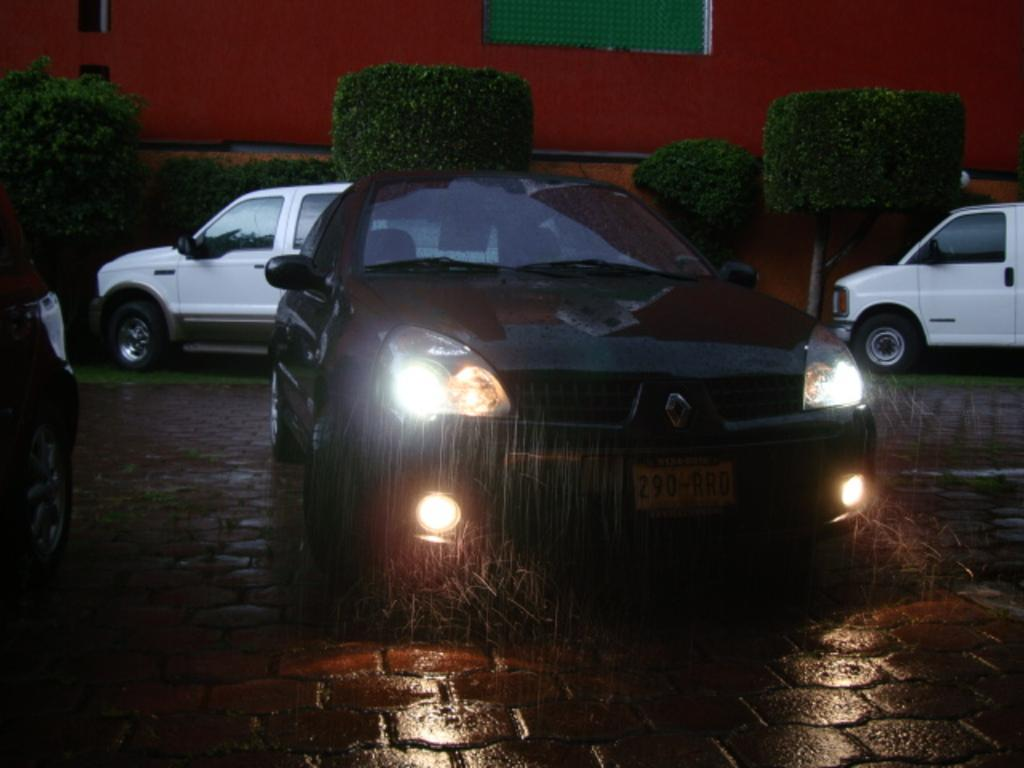What is the main subject in the center of the image? There is a car in the center of the image. What can be seen in the background of the image? There is a building in the background of the image. What type of vegetation is visible in the image? There are plants visible in the image. Are there any other cars in the image besides the one in the center? Yes, there are other cars in the image. What type of vessel is being used to cook in the image? There is no vessel or cooking activity present in the image. 